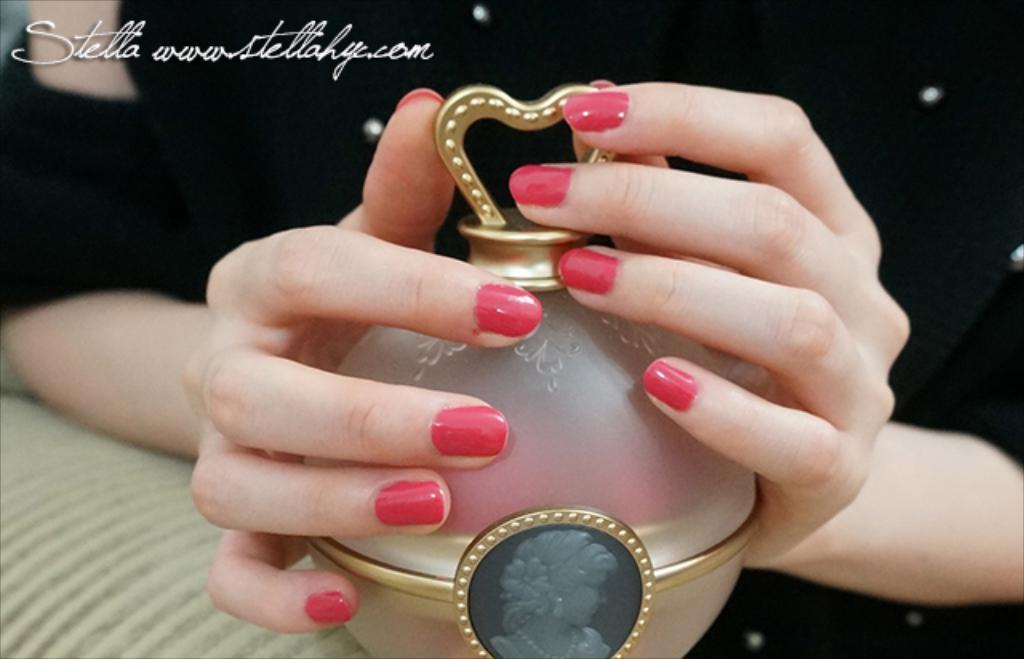What brand is this?
Give a very brief answer. Stella. Is there a website on this picture?
Provide a short and direct response. Yes. 